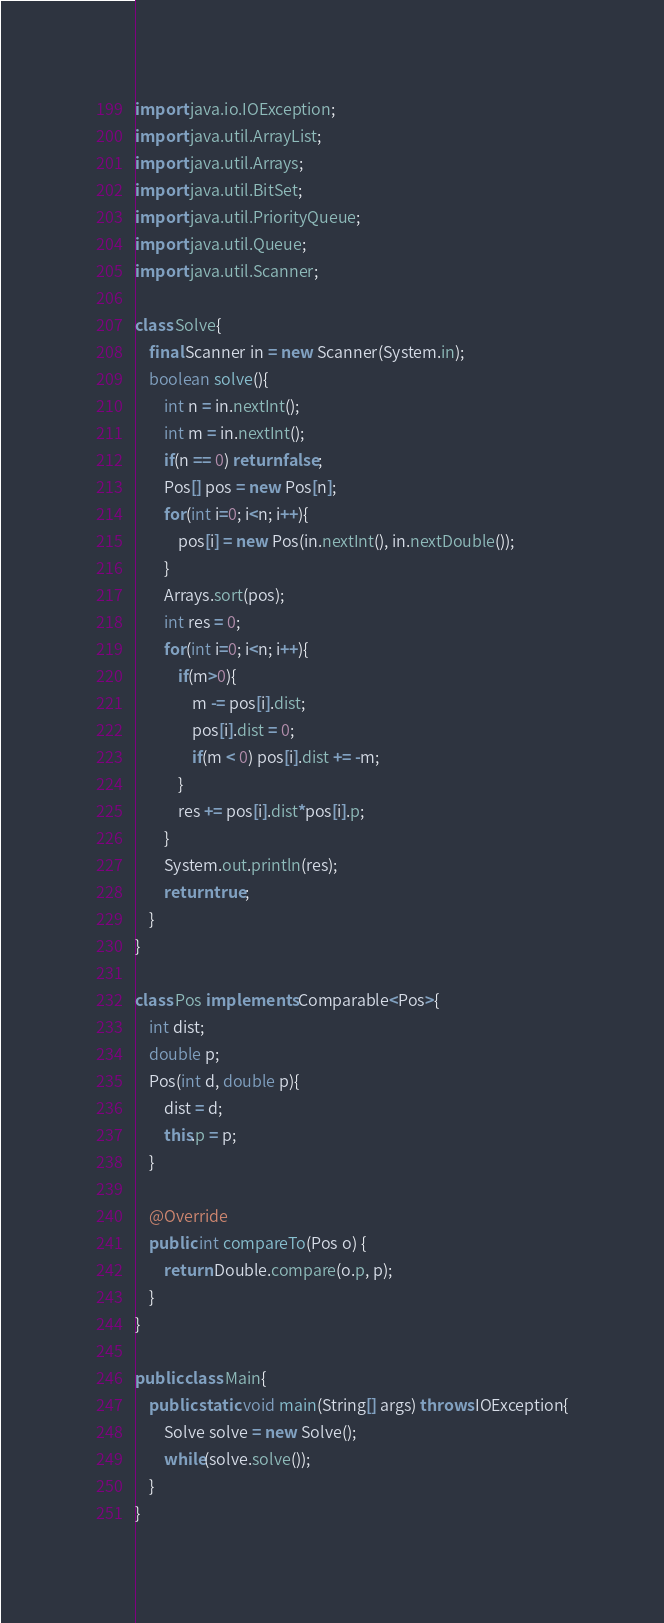<code> <loc_0><loc_0><loc_500><loc_500><_Java_>import java.io.IOException;
import java.util.ArrayList;
import java.util.Arrays;
import java.util.BitSet;
import java.util.PriorityQueue;
import java.util.Queue;
import java.util.Scanner;

class Solve{
	final Scanner in = new Scanner(System.in);
	boolean solve(){
		int n = in.nextInt();
		int m = in.nextInt();
		if(n == 0) return false;
		Pos[] pos = new Pos[n];
		for(int i=0; i<n; i++){
			pos[i] = new Pos(in.nextInt(), in.nextDouble());
		}
		Arrays.sort(pos);
		int res = 0;
		for(int i=0; i<n; i++){
			if(m>0){
				m -= pos[i].dist;
				pos[i].dist = 0;
				if(m < 0) pos[i].dist += -m;
			}
			res += pos[i].dist*pos[i].p;
		}
		System.out.println(res);
		return true;
	}
}

class Pos implements Comparable<Pos>{
	int dist;
	double p;
	Pos(int d, double p){
		dist = d;
		this.p = p;
	}
	
	@Override
	public int compareTo(Pos o) {
		return Double.compare(o.p, p);
	}
}

public class Main{
	public static void main(String[] args) throws IOException{
		Solve solve = new Solve();
		while(solve.solve());
	}
}</code> 